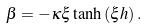<formula> <loc_0><loc_0><loc_500><loc_500>\beta = - \kappa \xi \tanh { \left ( \xi h \right ) } \, .</formula> 